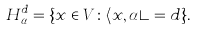<formula> <loc_0><loc_0><loc_500><loc_500>H _ { \alpha } ^ { d } = \{ x \in V \colon \langle x , \alpha \rangle = d \} .</formula> 